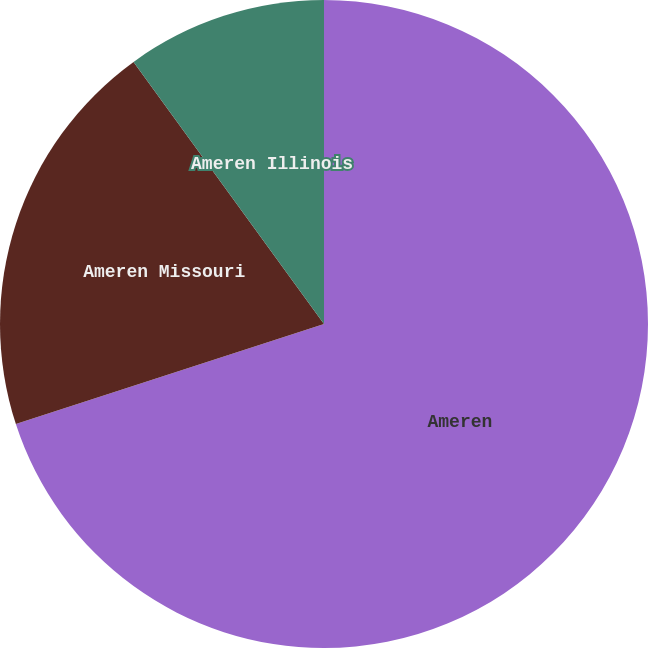Convert chart to OTSL. <chart><loc_0><loc_0><loc_500><loc_500><pie_chart><fcel>Ameren<fcel>Ameren Missouri<fcel>Ameren Illinois<nl><fcel>70.0%<fcel>20.0%<fcel>10.0%<nl></chart> 